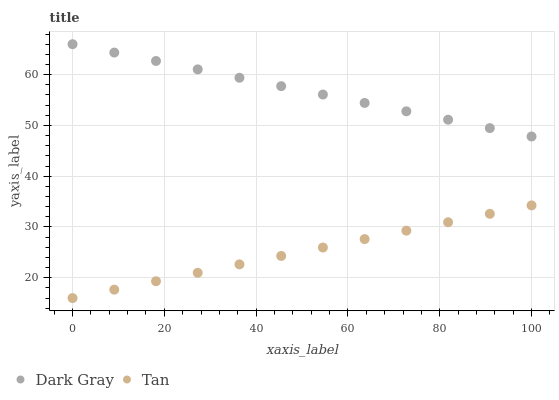Does Tan have the minimum area under the curve?
Answer yes or no. Yes. Does Dark Gray have the maximum area under the curve?
Answer yes or no. Yes. Does Tan have the maximum area under the curve?
Answer yes or no. No. Is Tan the smoothest?
Answer yes or no. Yes. Is Dark Gray the roughest?
Answer yes or no. Yes. Is Tan the roughest?
Answer yes or no. No. Does Tan have the lowest value?
Answer yes or no. Yes. Does Dark Gray have the highest value?
Answer yes or no. Yes. Does Tan have the highest value?
Answer yes or no. No. Is Tan less than Dark Gray?
Answer yes or no. Yes. Is Dark Gray greater than Tan?
Answer yes or no. Yes. Does Tan intersect Dark Gray?
Answer yes or no. No. 